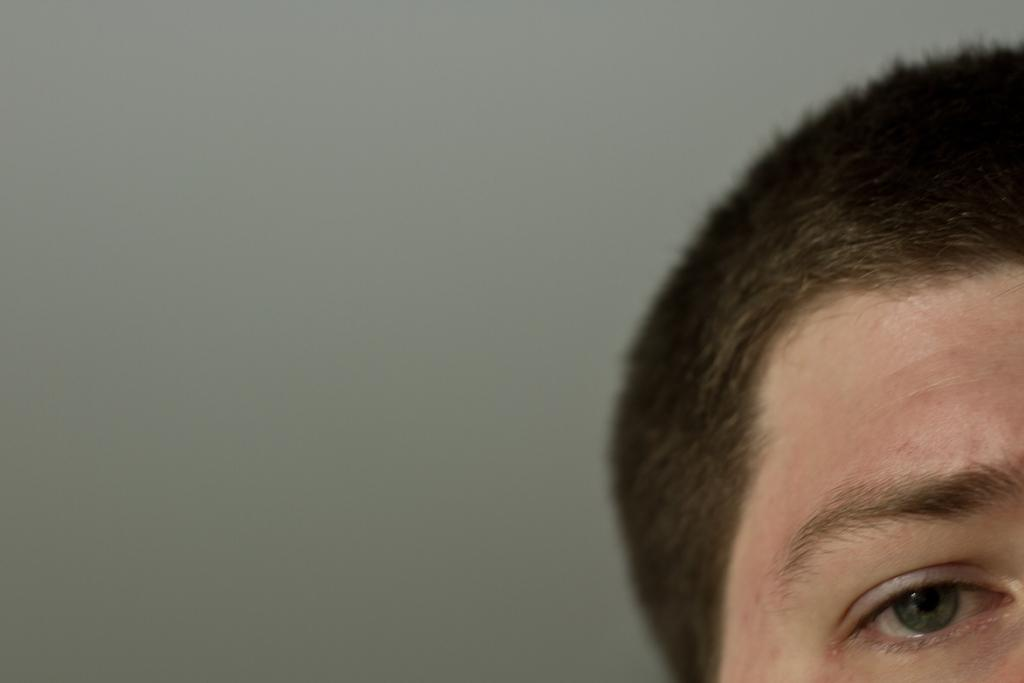What part of the body is visible in the image? There is a part of a head in the image. Which specific feature of the head can be seen? There is an eye visible in the image. What type of drink is being held by the lizards in the image? There are no lizards or drinks present in the image; it only features a part of a head and an eye. 